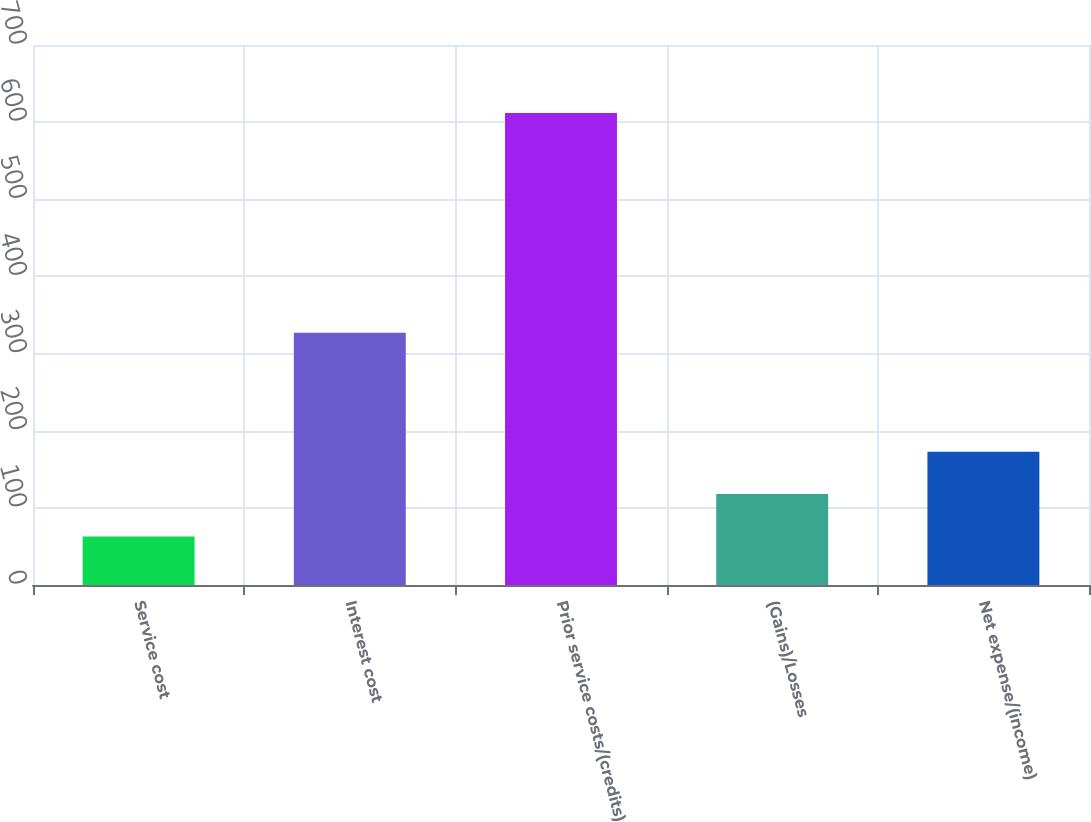<chart> <loc_0><loc_0><loc_500><loc_500><bar_chart><fcel>Service cost<fcel>Interest cost<fcel>Prior service costs/(credits)<fcel>(Gains)/Losses<fcel>Net expense/(income)<nl><fcel>63<fcel>327<fcel>612<fcel>117.9<fcel>172.8<nl></chart> 